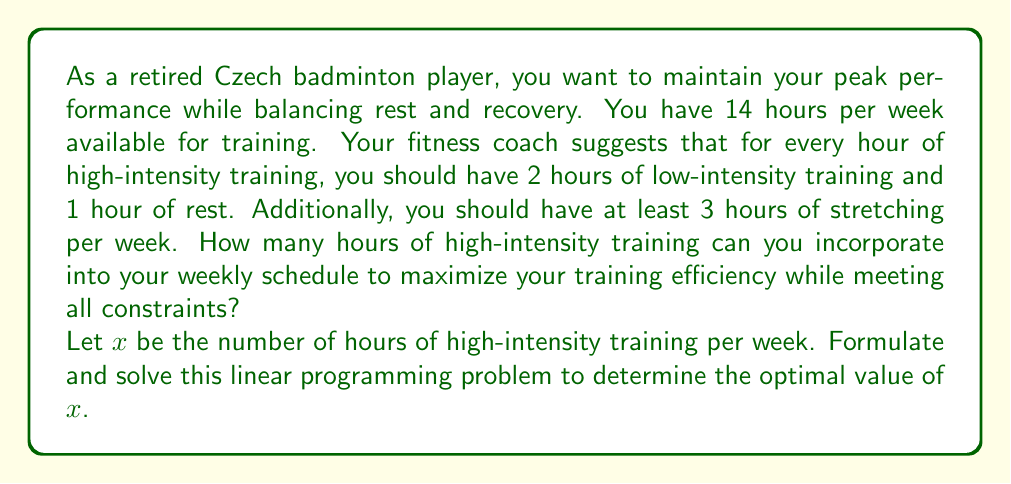What is the answer to this math problem? To solve this problem, we need to set up a linear programming model and then solve it. Let's break it down step by step:

1. Define variables:
   $x$ = hours of high-intensity training per week
   $2x$ = hours of low-intensity training per week (twice the high-intensity hours)
   $x$ = hours of rest per week (equal to high-intensity hours)
   $3$ = hours of stretching per week (minimum required)

2. Set up the objective function:
   We want to maximize the high-intensity training hours, so our objective function is:
   Maximize $z = x$

3. Identify constraints:
   a) Total time constraint: $x + 2x + x + 3 \leq 14$
   b) Non-negativity constraint: $x \geq 0$

4. Simplify the total time constraint:
   $4x + 3 \leq 14$
   $4x \leq 11$
   $x \leq \frac{11}{4} = 2.75$

5. Solve the linear programming problem:
   The optimal solution will be the largest value of $x$ that satisfies all constraints.
   From the simplified constraint, we can see that the maximum value of $x$ is $2.75$.

6. Check if the solution is an integer:
   Since we're dealing with hours, we need to round down to the nearest whole number.
   Therefore, the optimal solution is $x = 2$ hours of high-intensity training per week.

7. Verify the solution:
   With $x = 2$:
   - High-intensity training: 2 hours
   - Low-intensity training: 4 hours
   - Rest: 2 hours
   - Stretching: 3 hours
   Total: 11 hours, which is less than or equal to 14 hours available.
Answer: The optimal solution is 2 hours of high-intensity training per week. 